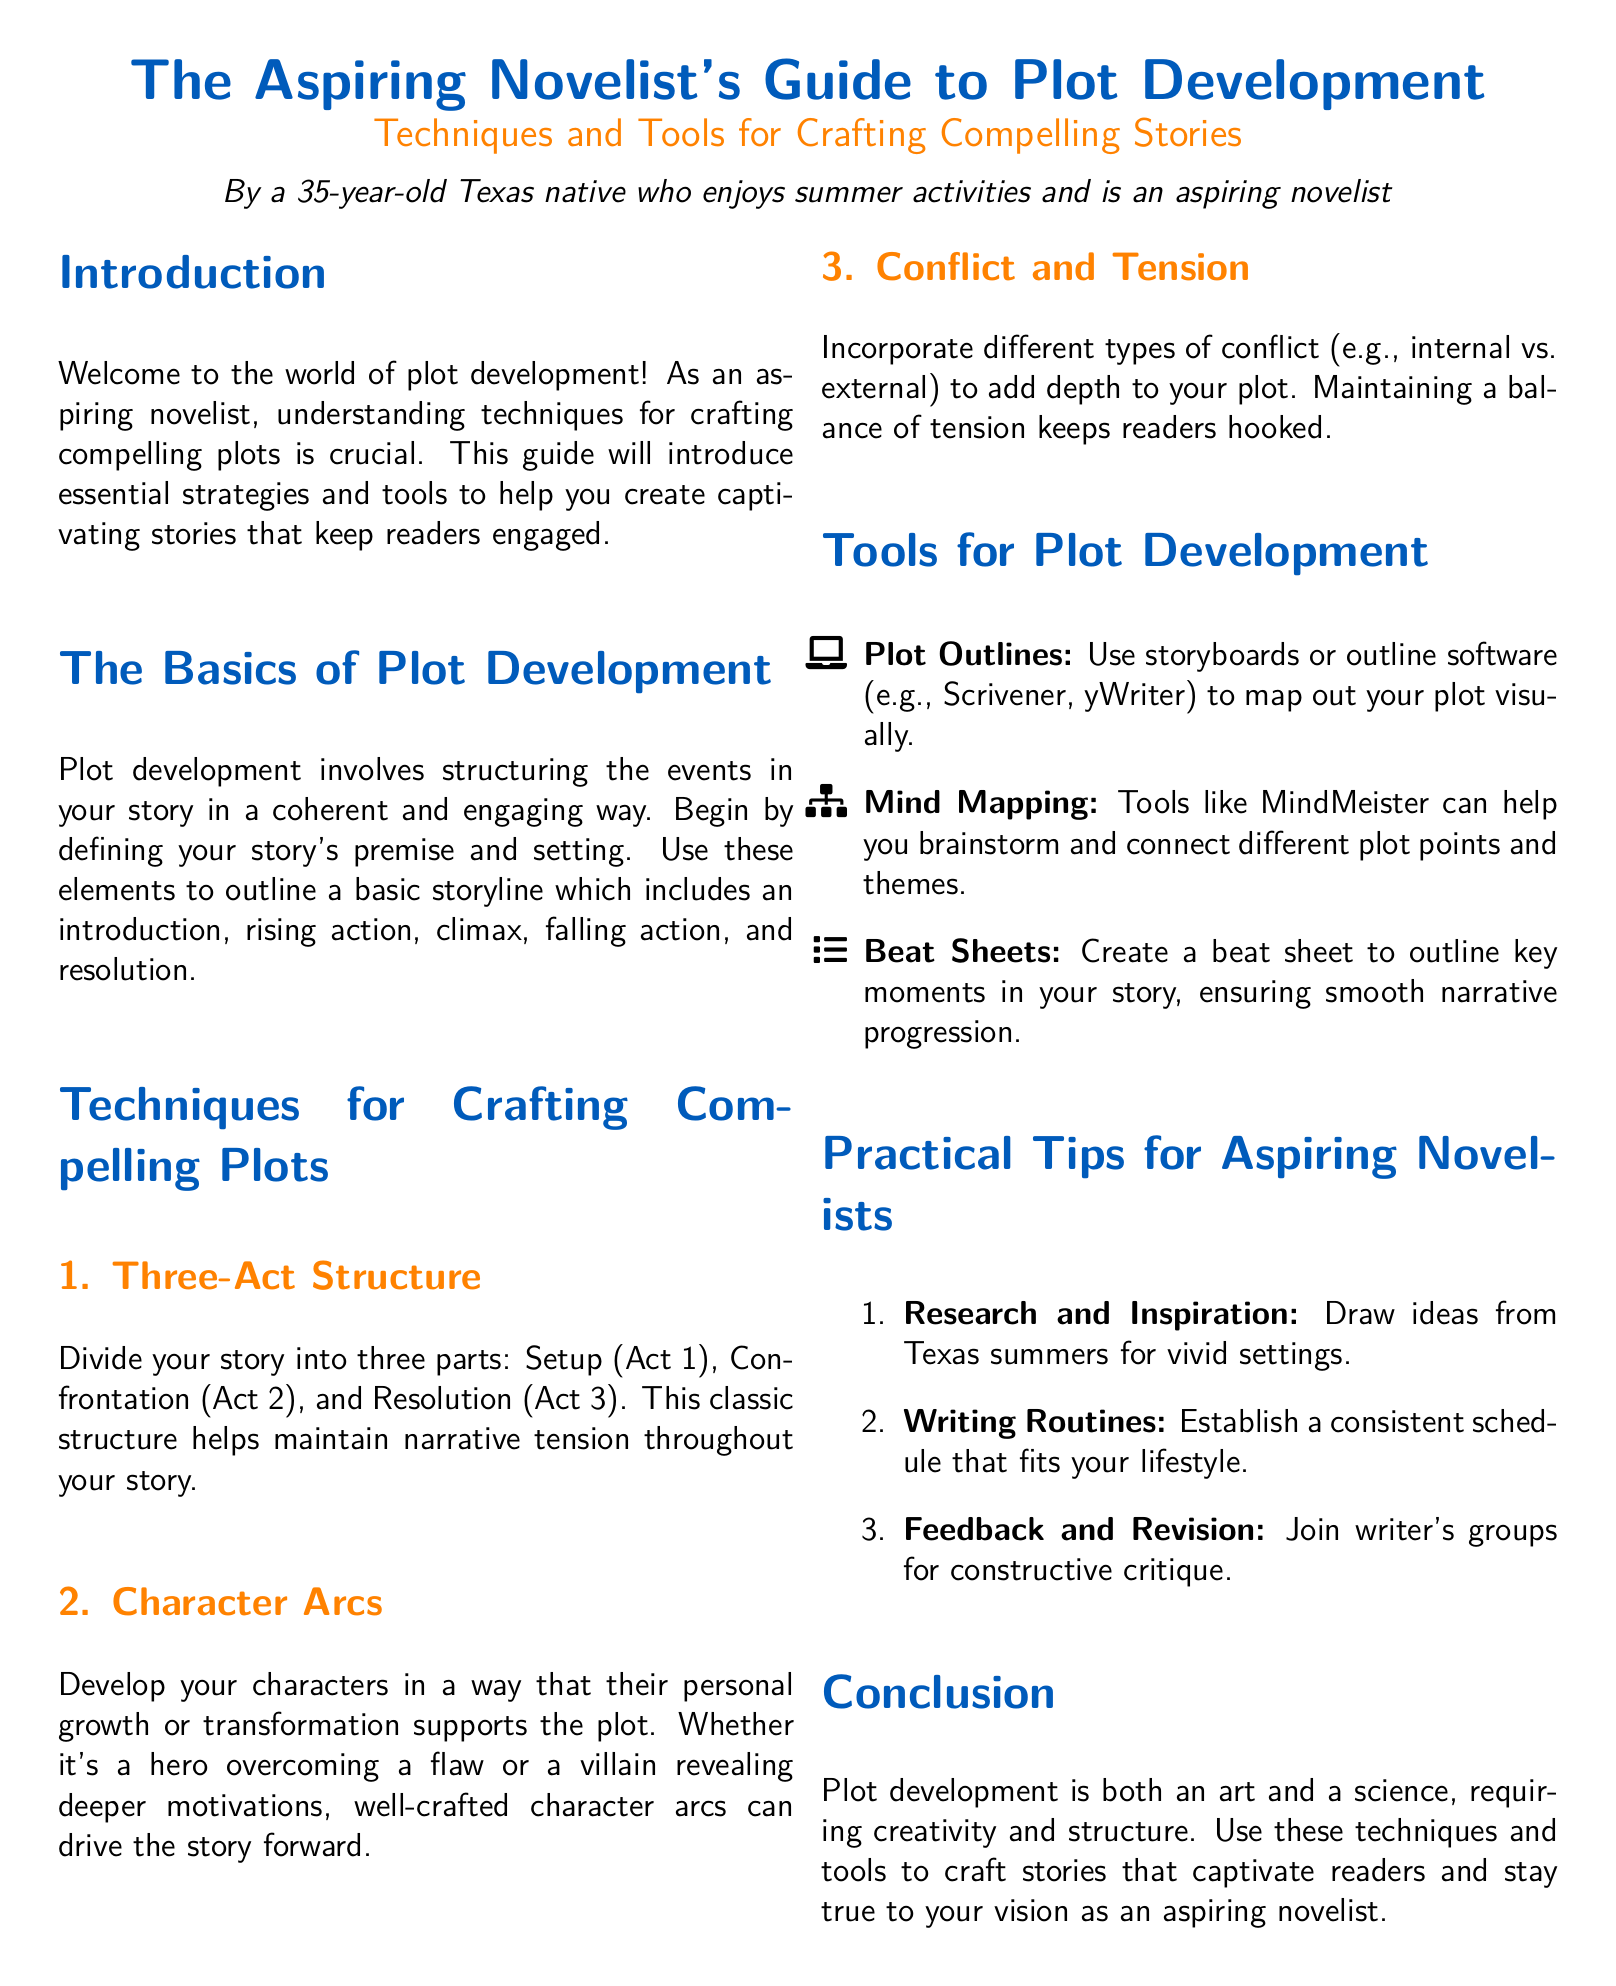What is the title of the guide? The title is prominently displayed at the beginning of the document.
Answer: The Aspiring Novelist's Guide to Plot Development Who is the author of the guide? The author is introduced in the introduction section of the document.
Answer: A 35-year-old Texas native What is the first technique for crafting compelling plots mentioned? The techniques are listed under a specific section in the document.
Answer: Three-Act Structure What are the types of conflict mentioned? The document discusses various types of conflict in the context of plot development.
Answer: Internal vs. external What tool is suggested for creating a visual plot outline? The tools for plot development are listed, with specific software options provided.
Answer: Scrivener How many acts are in the Three-Act Structure? The document specifies the number of acts that this structure is divided into.
Answer: Three What is a recommended practical tip for aspiring novelists? The practical tips are enumerated in a section of the document.
Answer: Research and Inspiration What formats are used for outlining plots? The tools section enumerates various formats used for organizing plots.
Answer: Storyboards, outline software What color is used for section titles? The document describes the colors used for different formatting.
Answer: Texas blue 